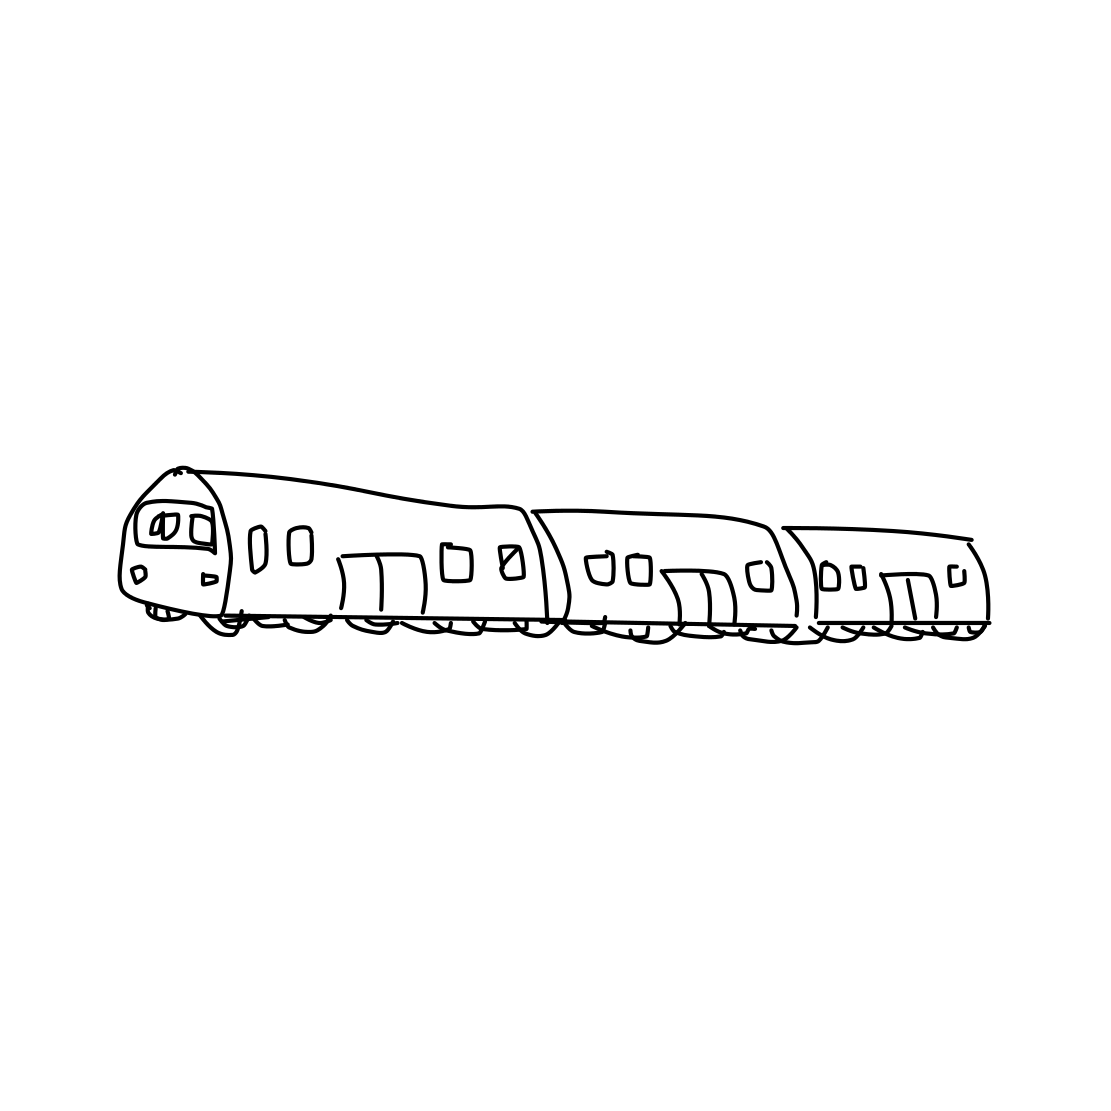What can you tell me about trains in general? Trains are a form of rail transport consisting of a series of vehicles propelled along a track to transport cargo or passengers. They offer important benefits like energy efficiency, reliability, and capacity for heavy loads or a large number of passengers. Trains have a rich history and continue to be a vital part of the transportation infrastructure in many countries. 